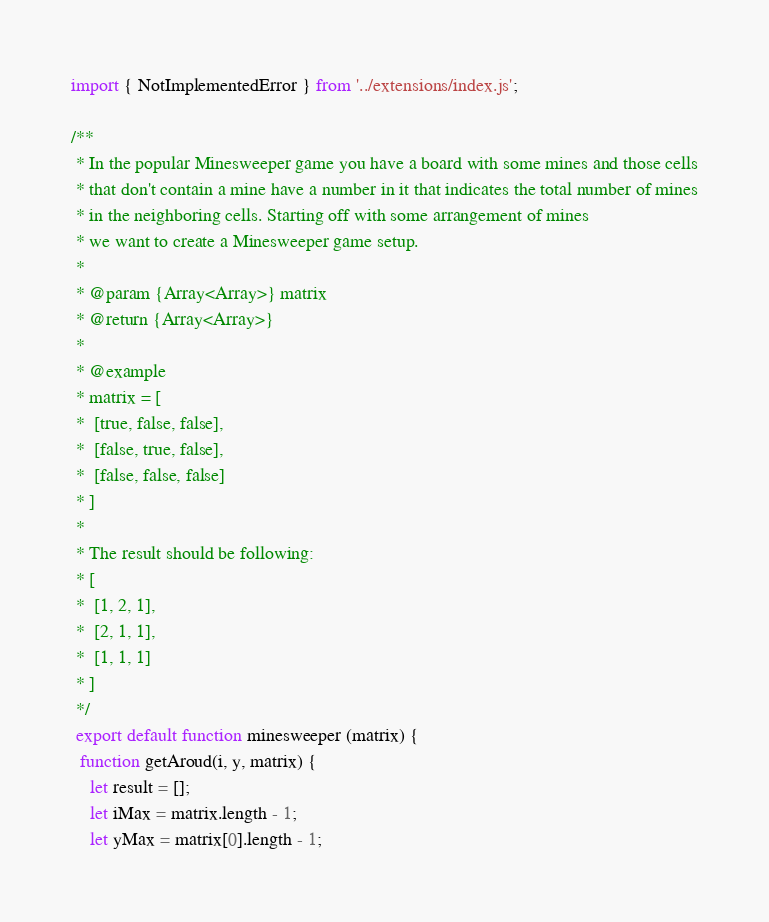Convert code to text. <code><loc_0><loc_0><loc_500><loc_500><_JavaScript_>import { NotImplementedError } from '../extensions/index.js';

/**
 * In the popular Minesweeper game you have a board with some mines and those cells
 * that don't contain a mine have a number in it that indicates the total number of mines
 * in the neighboring cells. Starting off with some arrangement of mines
 * we want to create a Minesweeper game setup.
 *
 * @param {Array<Array>} matrix
 * @return {Array<Array>}
 *
 * @example
 * matrix = [
 *  [true, false, false],
 *  [false, true, false],
 *  [false, false, false]
 * ]
 *
 * The result should be following:
 * [
 *  [1, 2, 1],
 *  [2, 1, 1],
 *  [1, 1, 1]
 * ]
 */
 export default function minesweeper (matrix) {
  function getAroud(i, y, matrix) {
    let result = [];
    let iMax = matrix.length - 1;
    let yMax = matrix[0].length - 1;
</code> 